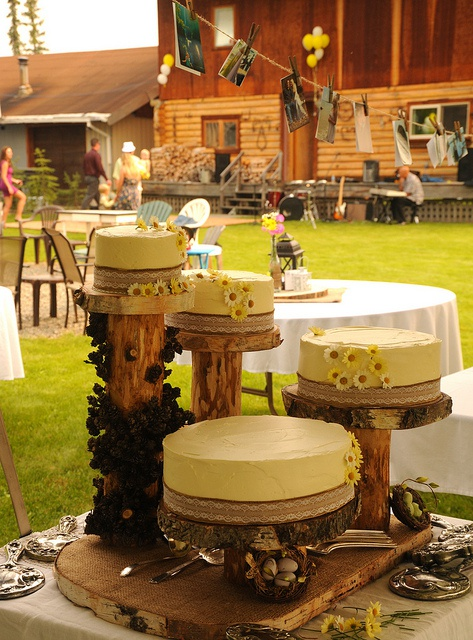Describe the objects in this image and their specific colors. I can see dining table in white, tan, black, and olive tones, cake in white, tan, and olive tones, cake in white, tan, olive, and khaki tones, dining table in white and tan tones, and dining table in white, tan, ivory, and olive tones in this image. 